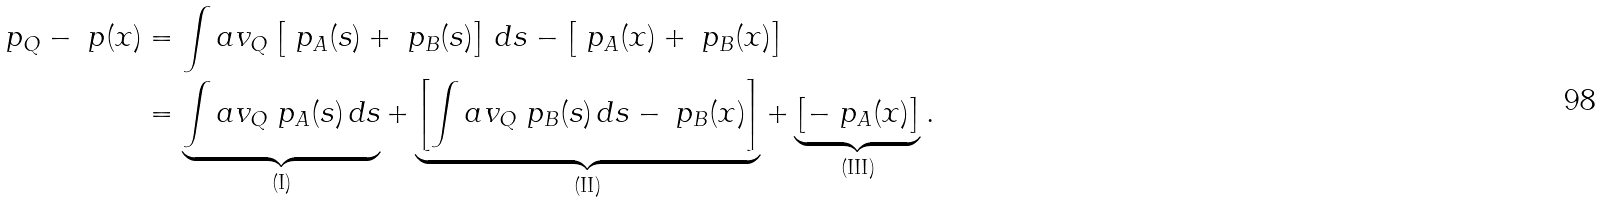<formula> <loc_0><loc_0><loc_500><loc_500>\ p _ { Q } - \ p ( x ) & = \int a v _ { Q } \left [ \ p _ { A } ( s ) + \ p _ { B } ( s ) \right ] \, d s - \left [ \ p _ { A } ( x ) + \ p _ { B } ( x ) \right ] \\ & = \underbrace { \int a v _ { Q } \ p _ { A } ( s ) \, d s } _ { ( \text {I} ) } + \underbrace { \left [ \int a v _ { Q } \ p _ { B } ( s ) \, d s - \ p _ { B } ( x ) \right ] } _ { ( \text {II} ) } + \underbrace { \left [ - \ p _ { A } ( x ) \right ] } _ { ( \text {III} ) } .</formula> 